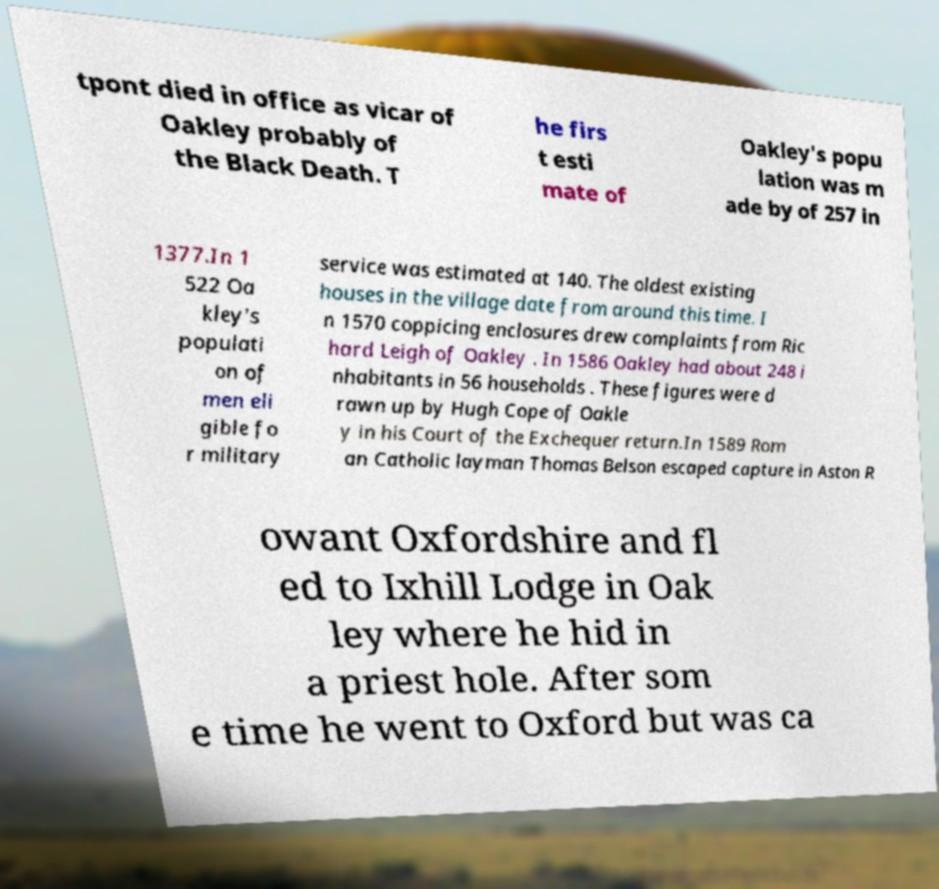Can you accurately transcribe the text from the provided image for me? tpont died in office as vicar of Oakley probably of the Black Death. T he firs t esti mate of Oakley's popu lation was m ade by of 257 in 1377.In 1 522 Oa kley's populati on of men eli gible fo r military service was estimated at 140. The oldest existing houses in the village date from around this time. I n 1570 coppicing enclosures drew complaints from Ric hard Leigh of Oakley . In 1586 Oakley had about 248 i nhabitants in 56 households . These figures were d rawn up by Hugh Cope of Oakle y in his Court of the Exchequer return.In 1589 Rom an Catholic layman Thomas Belson escaped capture in Aston R owant Oxfordshire and fl ed to Ixhill Lodge in Oak ley where he hid in a priest hole. After som e time he went to Oxford but was ca 